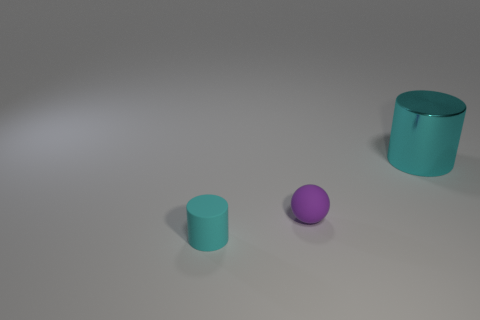What shape is the other thing that is the same size as the purple object?
Provide a succinct answer. Cylinder. What is the material of the big object?
Your answer should be very brief. Metal. There is another cyan object that is the same shape as the large cyan metallic object; what size is it?
Your answer should be compact. Small. Is the color of the big cylinder the same as the small cylinder?
Keep it short and to the point. Yes. What number of other objects are there of the same material as the tiny purple ball?
Your answer should be compact. 1. Are there the same number of tiny rubber balls on the left side of the large cyan cylinder and large green matte things?
Give a very brief answer. No. There is a rubber object that is behind the matte cylinder; is it the same size as the tiny cyan cylinder?
Provide a succinct answer. Yes. How many rubber cylinders are behind the big object?
Your answer should be compact. 0. What is the object that is both behind the tiny cyan object and on the left side of the cyan metal thing made of?
Ensure brevity in your answer.  Rubber. How many large things are metallic objects or cyan cylinders?
Give a very brief answer. 1. 